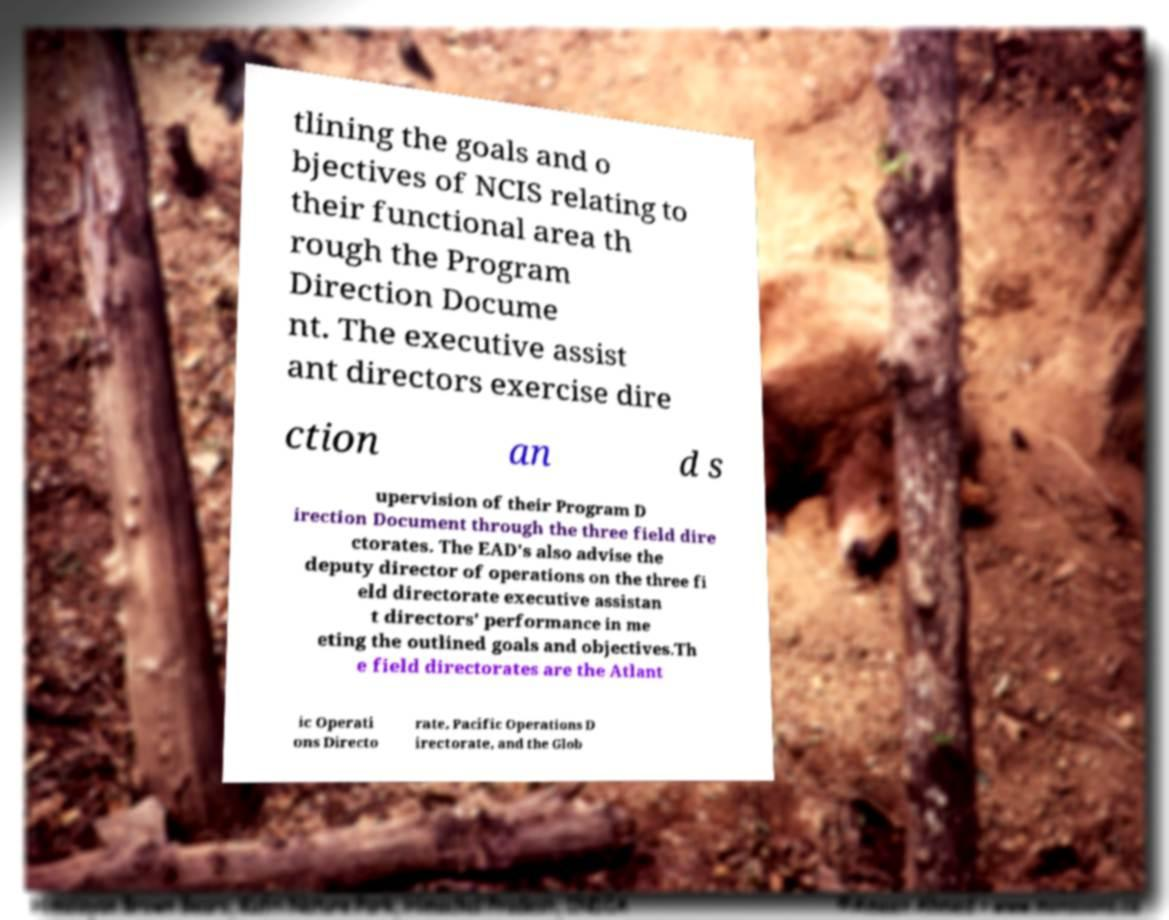There's text embedded in this image that I need extracted. Can you transcribe it verbatim? tlining the goals and o bjectives of NCIS relating to their functional area th rough the Program Direction Docume nt. The executive assist ant directors exercise dire ction an d s upervision of their Program D irection Document through the three field dire ctorates. The EAD's also advise the deputy director of operations on the three fi eld directorate executive assistan t directors' performance in me eting the outlined goals and objectives.Th e field directorates are the Atlant ic Operati ons Directo rate, Pacific Operations D irectorate, and the Glob 